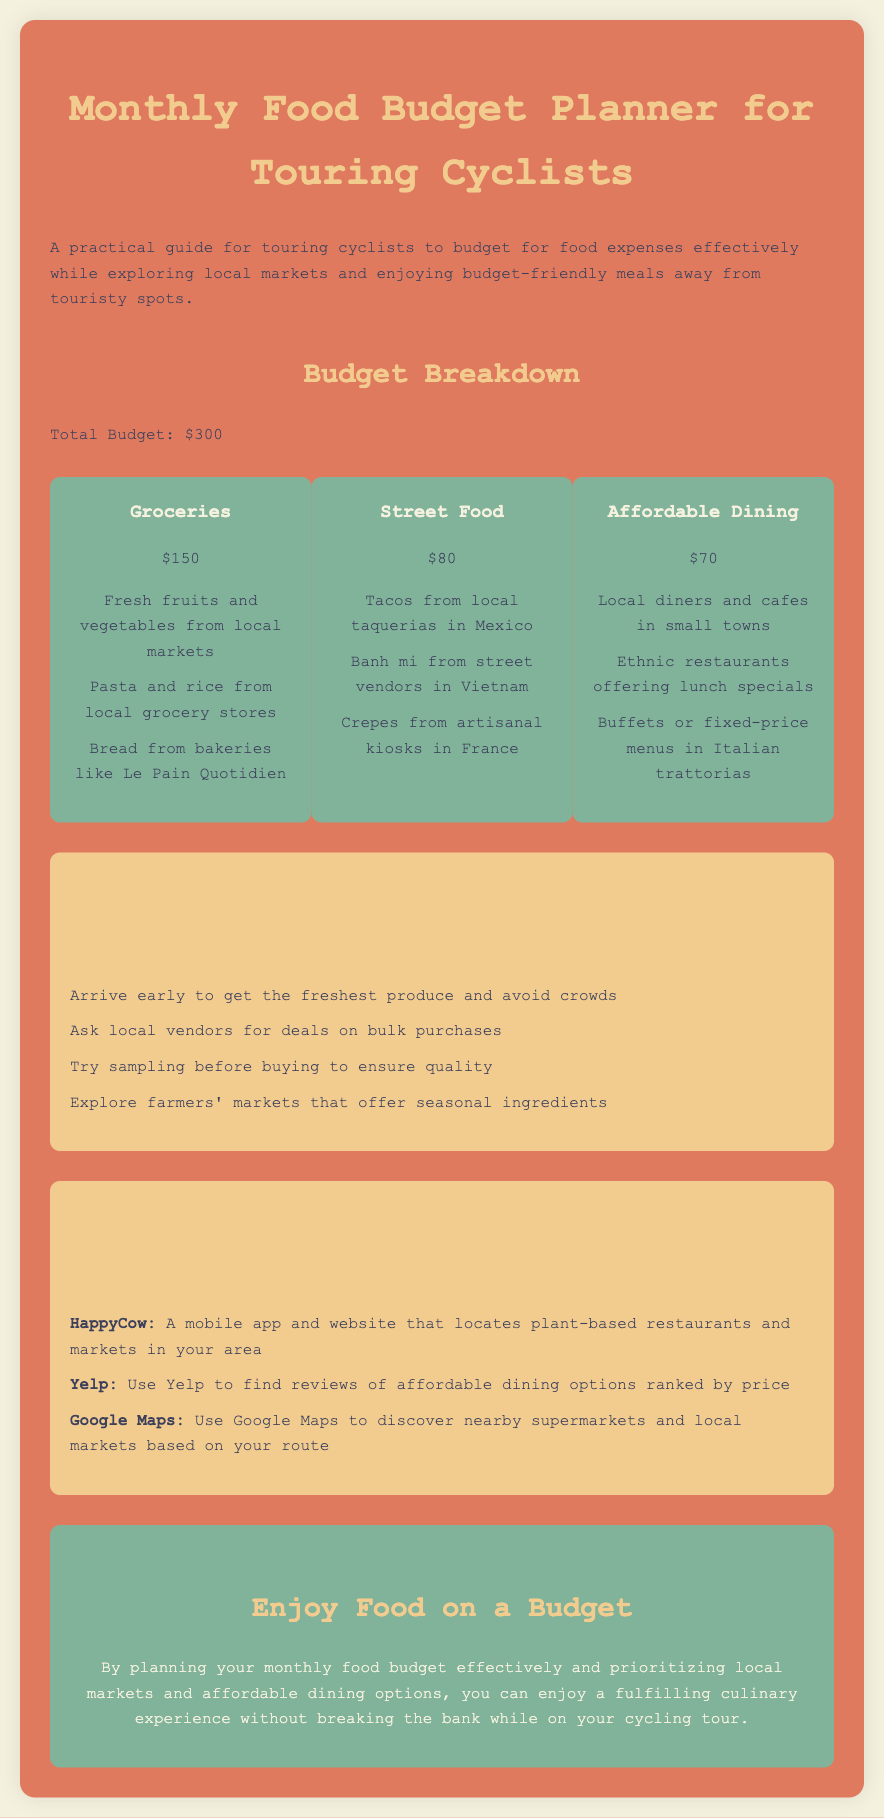What is the total budget for the food planner? The total budget is mentioned as $300 in the document.
Answer: $300 How much is allocated for groceries? The section on groceries indicates the budget allocated is $150.
Answer: $150 What type of food is listed under Street Food? The street food category includes items like tacos, banh mi, and crepes.
Answer: Tacos, banh mi, crepes What is one tip for shopping at local markets? The document lists several tips, one of which includes arriving early for fresh produce.
Answer: Arrive early What resource helps locate plant-based restaurants? The application mentioned for finding plant-based restaurants is HappyCow.
Answer: HappyCow What percentage of the total budget is allocated to Street Food? The Street Food budget of $80 is 26.67% of the total budget of $300.
Answer: 26.67% Which style of dining is mentioned as "Affordable Dining"? Affordable Dining refers to local diners and cafes in small towns.
Answer: Local diners and cafes What is a benefit of exploring farmers' markets? The document implies that farmers' markets offer seasonal ingredients, which is an advantage.
Answer: Seasonal ingredients How can Google Maps assist cyclists? Google Maps is useful for discovering nearby supermarkets and local markets along the route.
Answer: Discover nearby supermarkets and local markets 